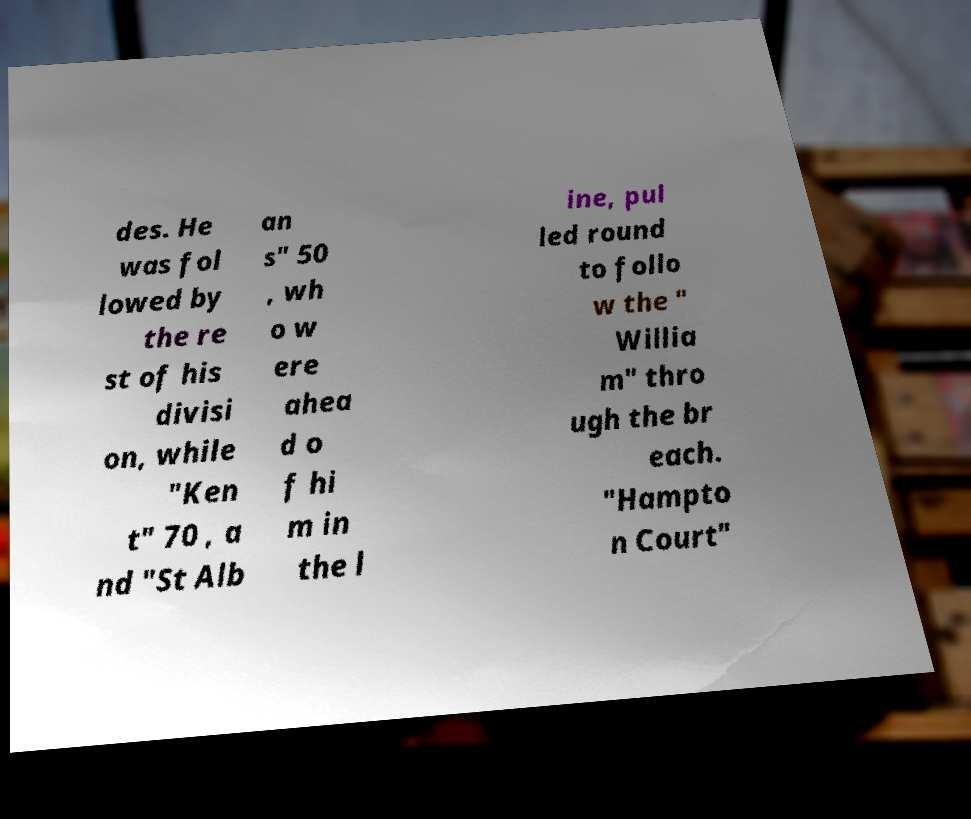I need the written content from this picture converted into text. Can you do that? des. He was fol lowed by the re st of his divisi on, while "Ken t" 70 , a nd "St Alb an s" 50 , wh o w ere ahea d o f hi m in the l ine, pul led round to follo w the " Willia m" thro ugh the br each. "Hampto n Court" 